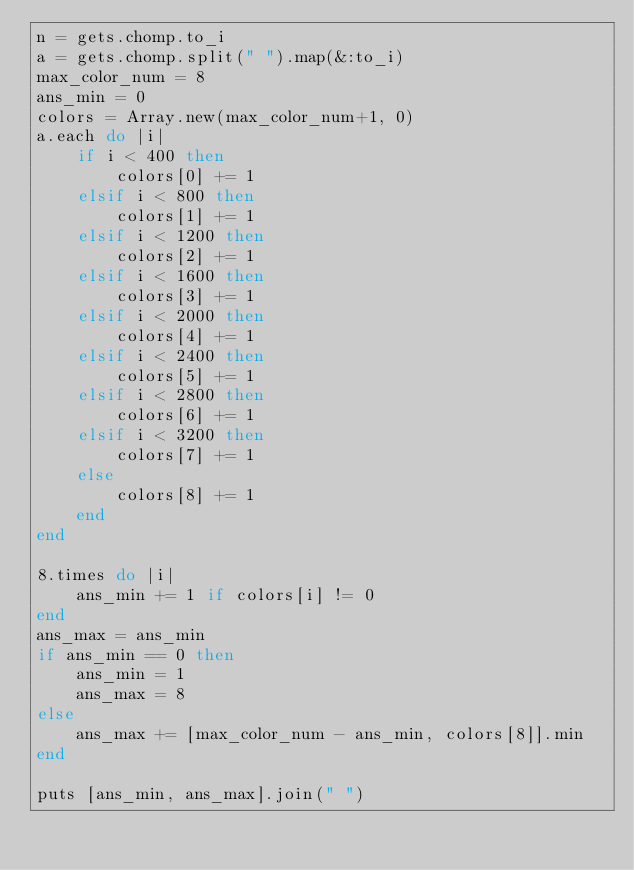Convert code to text. <code><loc_0><loc_0><loc_500><loc_500><_Ruby_>n = gets.chomp.to_i
a = gets.chomp.split(" ").map(&:to_i)
max_color_num = 8
ans_min = 0
colors = Array.new(max_color_num+1, 0)
a.each do |i|
    if i < 400 then
        colors[0] += 1
    elsif i < 800 then
        colors[1] += 1
    elsif i < 1200 then
        colors[2] += 1
    elsif i < 1600 then
        colors[3] += 1
    elsif i < 2000 then
        colors[4] += 1
    elsif i < 2400 then
        colors[5] += 1
    elsif i < 2800 then
        colors[6] += 1
    elsif i < 3200 then
        colors[7] += 1
    else
        colors[8] += 1
    end
end

8.times do |i|
    ans_min += 1 if colors[i] != 0
end
ans_max = ans_min
if ans_min == 0 then
    ans_min = 1
    ans_max = 8
else
    ans_max += [max_color_num - ans_min, colors[8]].min
end

puts [ans_min, ans_max].join(" ")</code> 